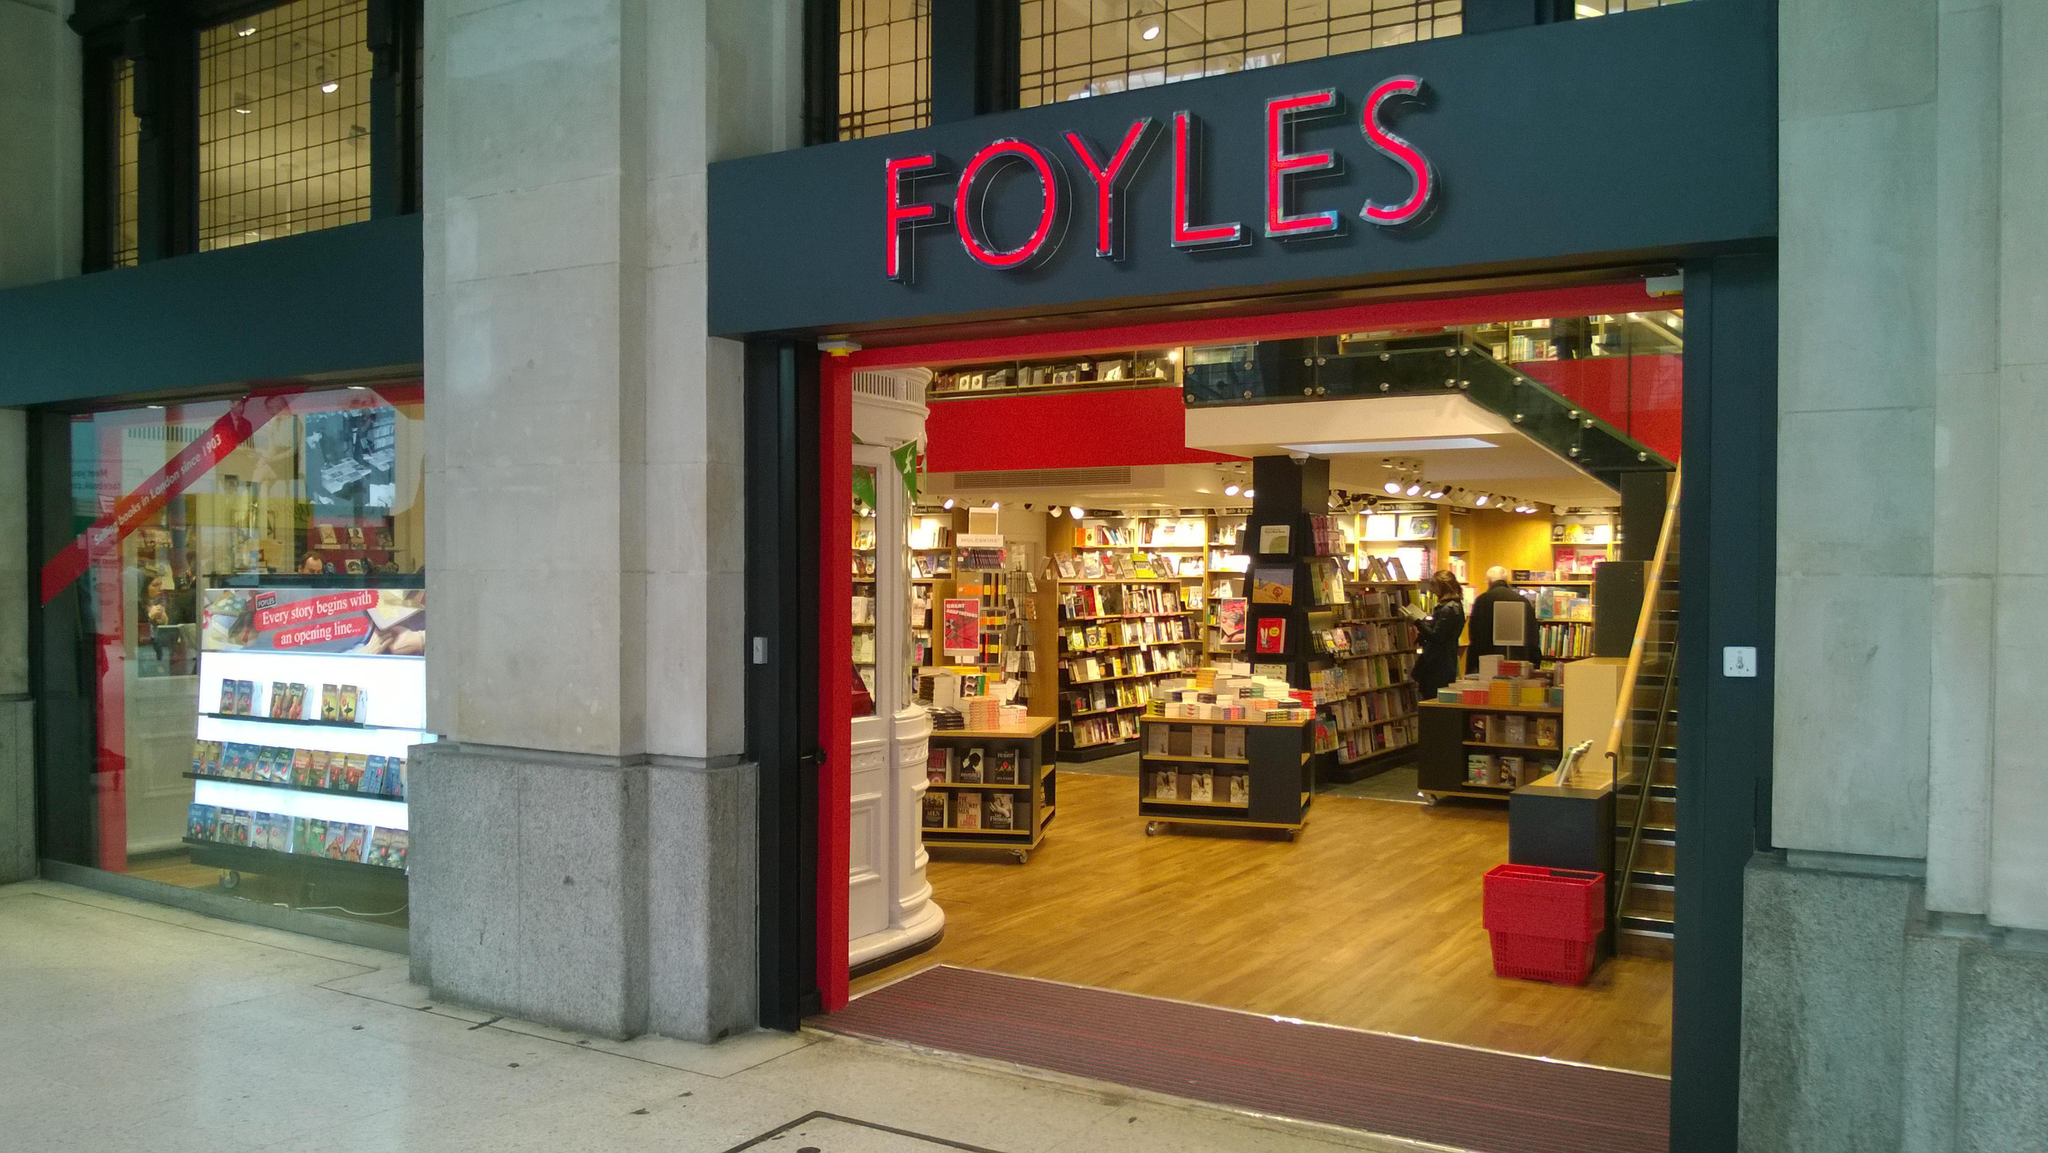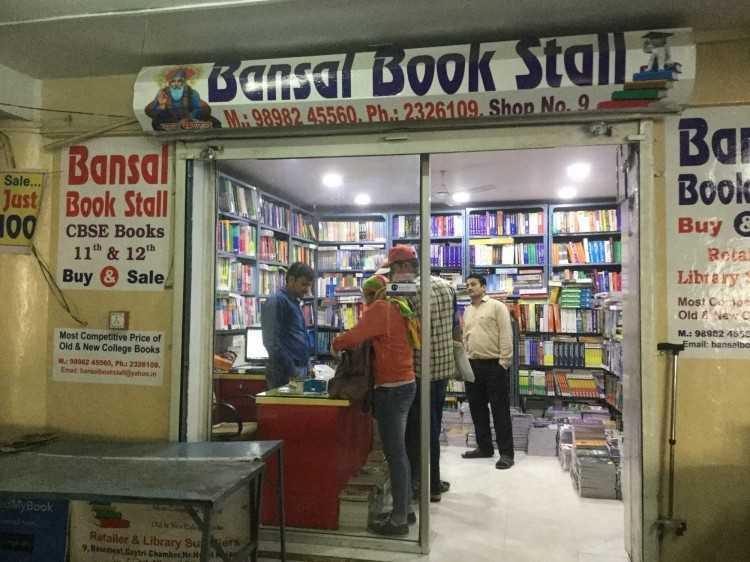The first image is the image on the left, the second image is the image on the right. Considering the images on both sides, is "In one image, a clerk can be seen to the left behind a counter of a bookstore, bookshelves extending down that wall and across the back, with three customers in the store." valid? Answer yes or no. Yes. The first image is the image on the left, the second image is the image on the right. For the images displayed, is the sentence "Both images show store exteriors with red-background signs above the entrance." factually correct? Answer yes or no. No. 